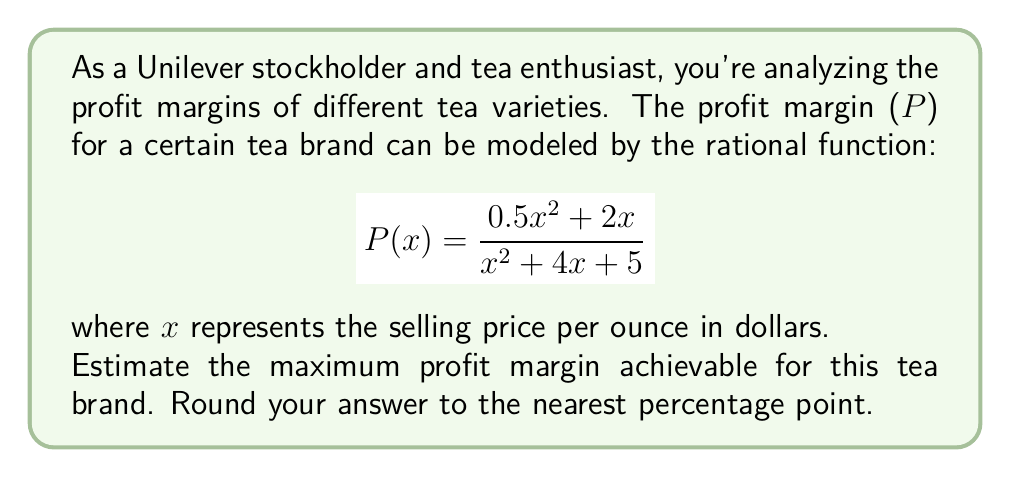Can you solve this math problem? To find the maximum profit margin, we need to follow these steps:

1) First, we need to find the critical points of the function. To do this, we take the derivative of P(x) and set it equal to zero.

2) The derivative of P(x) is:

   $$P'(x) = \frac{(x^2 + 4x + 5)(x + 2) - (0.5x^2 + 2x)(2x + 4)}{(x^2 + 4x + 5)^2}$$

3) Simplifying the numerator:

   $$P'(x) = \frac{x^3 + 6x^2 + 13x + 10 - x^3 - 6x^2 - 5x}{(x^2 + 4x + 5)^2} = \frac{8x + 10}{(x^2 + 4x + 5)^2}$$

4) Setting this equal to zero:

   $$\frac{8x + 10}{(x^2 + 4x + 5)^2} = 0$$

5) The denominator is always positive, so the numerator must be zero:

   $$8x + 10 = 0$$
   $$x = -\frac{5}{4}$$

6) However, since price can't be negative, this critical point is not in our domain. This means the maximum must occur at the endpoint of our domain, which is as x approaches infinity.

7) To find the limit as x approaches infinity, we divide both numerator and denominator by the highest power of x in the denominator:

   $$\lim_{x \to \infty} P(x) = \lim_{x \to \infty} \frac{0.5x^2 + 2x}{x^2 + 4x + 5} = \lim_{x \to \infty} \frac{0.5 + \frac{2}{x}}{1 + \frac{4}{x} + \frac{5}{x^2}} = 0.5$$

8) Converting to a percentage: 0.5 * 100 = 50%

Therefore, the maximum profit margin achievable is approximately 50%.
Answer: 50% 